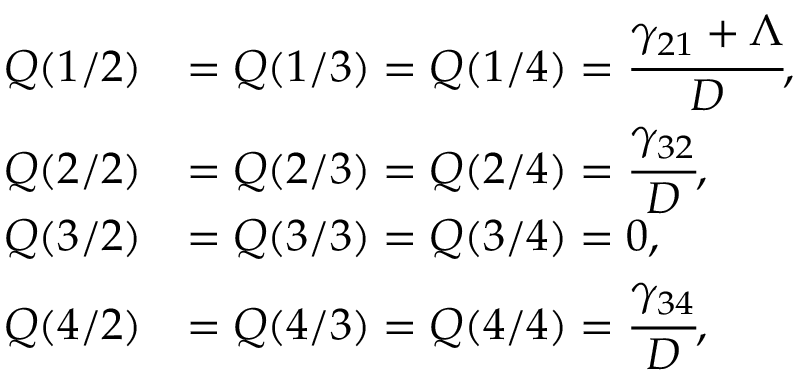<formula> <loc_0><loc_0><loc_500><loc_500>\begin{array} { r l } { Q ( 1 / 2 ) } & { = Q ( 1 / 3 ) = Q ( 1 / 4 ) = \cfrac { \gamma _ { 2 1 } + \Lambda } { D } , } \\ { Q ( 2 / 2 ) } & { = Q ( 2 / 3 ) = Q ( 2 / 4 ) = \cfrac { \gamma _ { 3 2 } } { D } , } \\ { Q ( 3 / 2 ) } & { = Q ( 3 / 3 ) = Q ( 3 / 4 ) = 0 , } \\ { Q ( 4 / 2 ) } & { = Q ( 4 / 3 ) = Q ( 4 / 4 ) = \cfrac { \gamma _ { 3 4 } } { D } , } \end{array}</formula> 